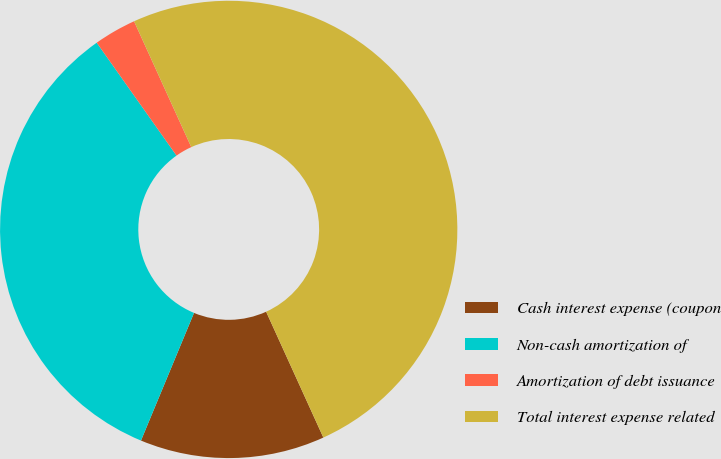<chart> <loc_0><loc_0><loc_500><loc_500><pie_chart><fcel>Cash interest expense (coupon<fcel>Non-cash amortization of<fcel>Amortization of debt issuance<fcel>Total interest expense related<nl><fcel>13.06%<fcel>33.94%<fcel>3.0%<fcel>50.0%<nl></chart> 